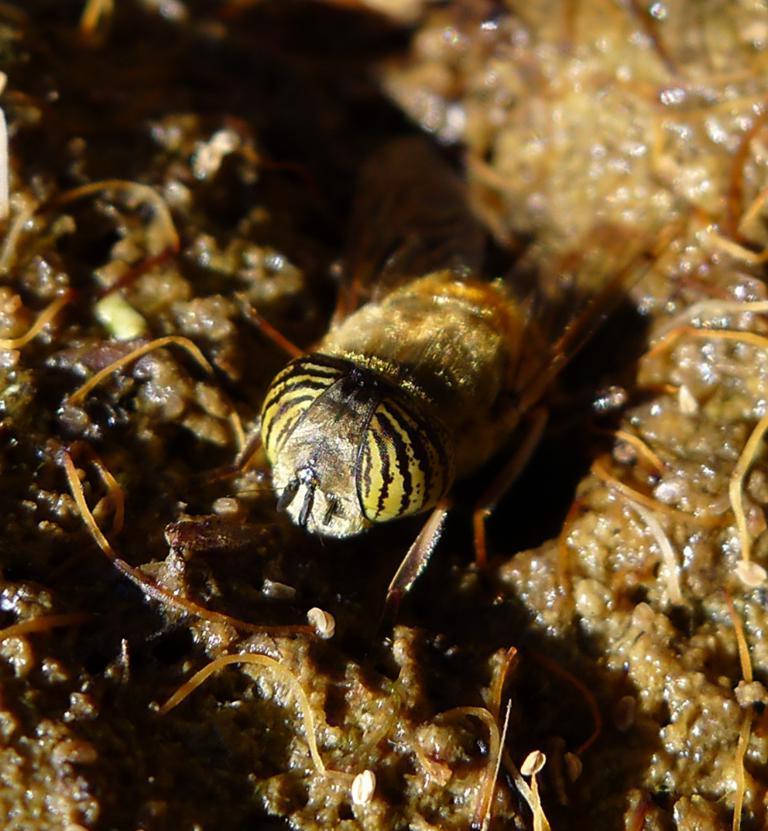Please provide a concise description of this image. Here we can see an insect on a wet surface. 